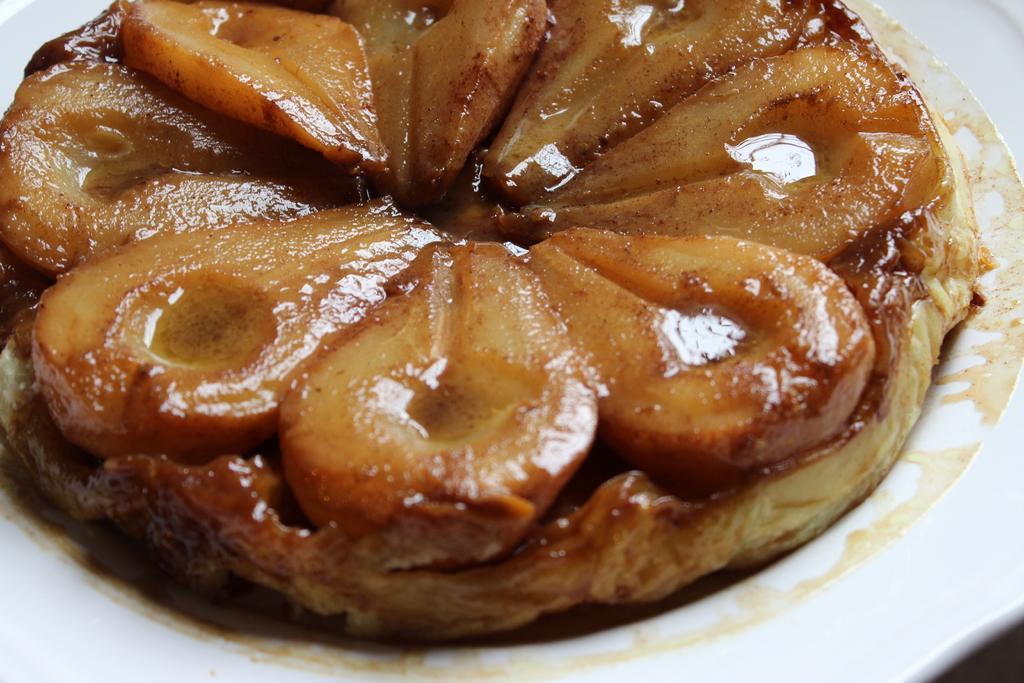How would you summarize this image in a sentence or two? In this image, we can see a food item kept in a white color plate. 